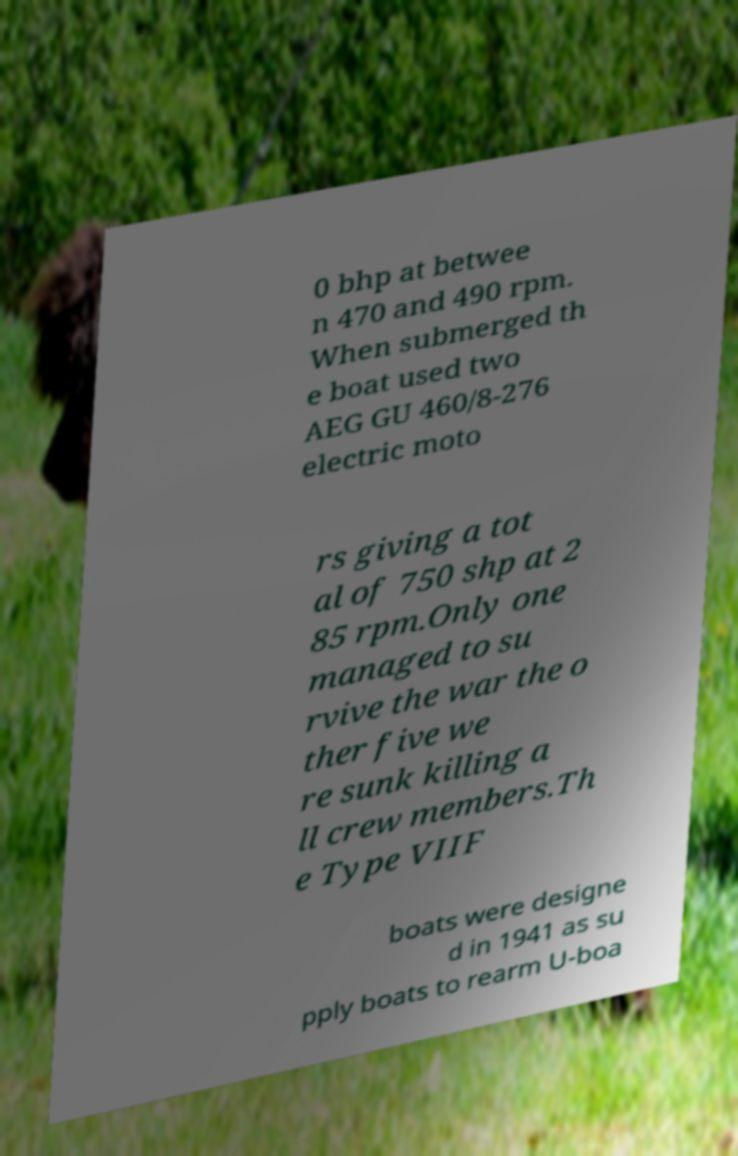For documentation purposes, I need the text within this image transcribed. Could you provide that? 0 bhp at betwee n 470 and 490 rpm. When submerged th e boat used two AEG GU 460/8-276 electric moto rs giving a tot al of 750 shp at 2 85 rpm.Only one managed to su rvive the war the o ther five we re sunk killing a ll crew members.Th e Type VIIF boats were designe d in 1941 as su pply boats to rearm U-boa 